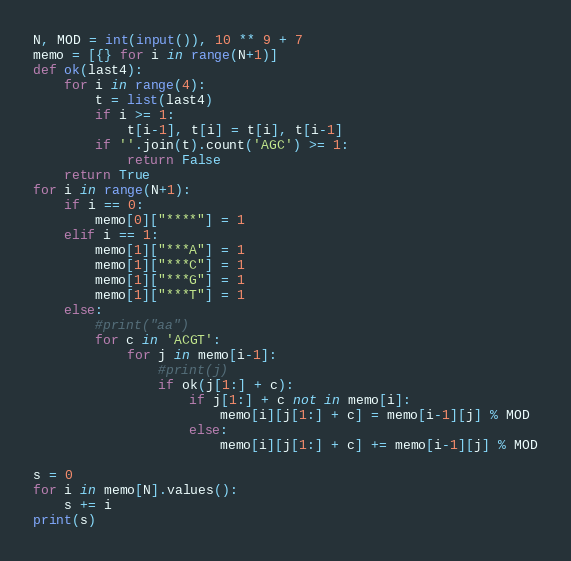Convert code to text. <code><loc_0><loc_0><loc_500><loc_500><_Python_>N, MOD = int(input()), 10 ** 9 + 7
memo = [{} for i in range(N+1)]
def ok(last4):
    for i in range(4):
        t = list(last4)
        if i >= 1:
            t[i-1], t[i] = t[i], t[i-1]
        if ''.join(t).count('AGC') >= 1:
            return False
    return True
for i in range(N+1):
    if i == 0:
        memo[0]["****"] = 1
    elif i == 1:
        memo[1]["***A"] = 1
        memo[1]["***C"] = 1
        memo[1]["***G"] = 1
        memo[1]["***T"] = 1
    else:
        #print("aa")
        for c in 'ACGT':
            for j in memo[i-1]:
                #print(j)
                if ok(j[1:] + c):
                    if j[1:] + c not in memo[i]:               
                        memo[i][j[1:] + c] = memo[i-1][j] % MOD
                    else:
                        memo[i][j[1:] + c] += memo[i-1][j] % MOD

s = 0
for i in memo[N].values():
    s += i
print(s)</code> 